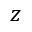Convert formula to latex. <formula><loc_0><loc_0><loc_500><loc_500>z</formula> 